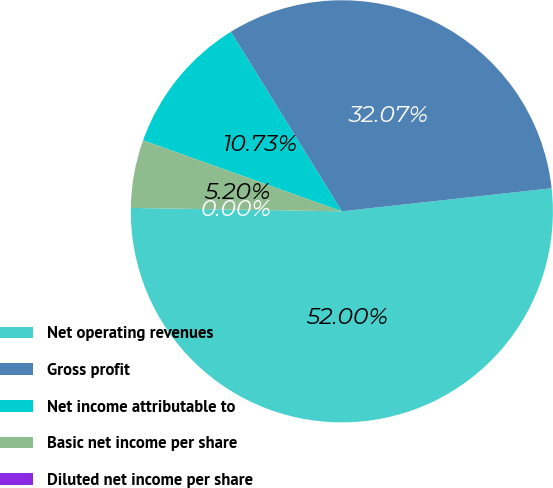Convert chart to OTSL. <chart><loc_0><loc_0><loc_500><loc_500><pie_chart><fcel>Net operating revenues<fcel>Gross profit<fcel>Net income attributable to<fcel>Basic net income per share<fcel>Diluted net income per share<nl><fcel>52.0%<fcel>32.07%<fcel>10.73%<fcel>5.2%<fcel>0.0%<nl></chart> 